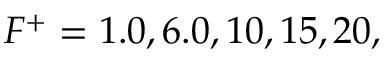<formula> <loc_0><loc_0><loc_500><loc_500>F ^ { + } = 1 . 0 , 6 . 0 , 1 0 , 1 5 , 2 0 ,</formula> 